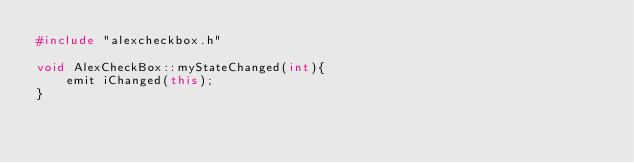<code> <loc_0><loc_0><loc_500><loc_500><_C++_>#include "alexcheckbox.h"

void AlexCheckBox::myStateChanged(int){
    emit iChanged(this);
}
</code> 